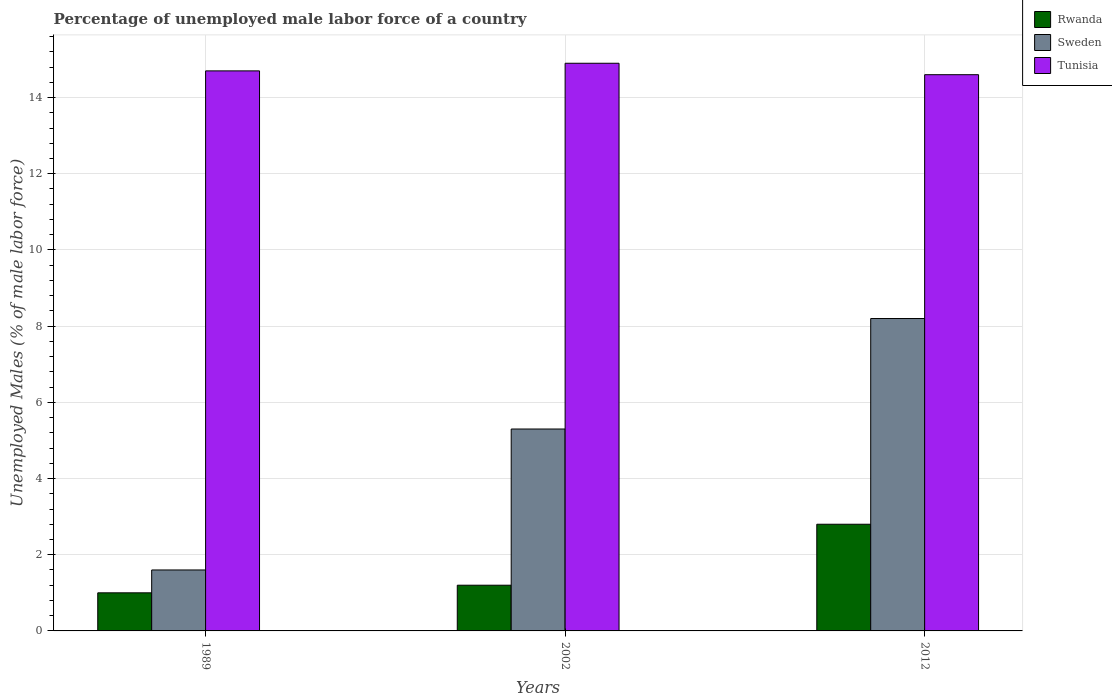How many different coloured bars are there?
Offer a very short reply. 3. How many bars are there on the 1st tick from the left?
Offer a very short reply. 3. What is the label of the 3rd group of bars from the left?
Ensure brevity in your answer.  2012. What is the percentage of unemployed male labor force in Tunisia in 2012?
Provide a short and direct response. 14.6. Across all years, what is the maximum percentage of unemployed male labor force in Rwanda?
Make the answer very short. 2.8. Across all years, what is the minimum percentage of unemployed male labor force in Tunisia?
Keep it short and to the point. 14.6. What is the total percentage of unemployed male labor force in Tunisia in the graph?
Provide a succinct answer. 44.2. What is the difference between the percentage of unemployed male labor force in Tunisia in 1989 and that in 2012?
Your answer should be very brief. 0.1. What is the difference between the percentage of unemployed male labor force in Sweden in 1989 and the percentage of unemployed male labor force in Tunisia in 2002?
Your answer should be compact. -13.3. What is the average percentage of unemployed male labor force in Sweden per year?
Keep it short and to the point. 5.03. In the year 1989, what is the difference between the percentage of unemployed male labor force in Rwanda and percentage of unemployed male labor force in Sweden?
Offer a very short reply. -0.6. What is the ratio of the percentage of unemployed male labor force in Rwanda in 1989 to that in 2002?
Offer a very short reply. 0.83. Is the percentage of unemployed male labor force in Rwanda in 1989 less than that in 2002?
Your answer should be very brief. Yes. Is the difference between the percentage of unemployed male labor force in Rwanda in 2002 and 2012 greater than the difference between the percentage of unemployed male labor force in Sweden in 2002 and 2012?
Your response must be concise. Yes. What is the difference between the highest and the second highest percentage of unemployed male labor force in Sweden?
Your answer should be very brief. 2.9. What is the difference between the highest and the lowest percentage of unemployed male labor force in Rwanda?
Provide a short and direct response. 1.8. What does the 3rd bar from the left in 2012 represents?
Provide a succinct answer. Tunisia. What does the 1st bar from the right in 2002 represents?
Keep it short and to the point. Tunisia. Is it the case that in every year, the sum of the percentage of unemployed male labor force in Tunisia and percentage of unemployed male labor force in Rwanda is greater than the percentage of unemployed male labor force in Sweden?
Provide a short and direct response. Yes. Are all the bars in the graph horizontal?
Make the answer very short. No. How many years are there in the graph?
Your answer should be compact. 3. What is the difference between two consecutive major ticks on the Y-axis?
Your response must be concise. 2. Are the values on the major ticks of Y-axis written in scientific E-notation?
Give a very brief answer. No. Does the graph contain any zero values?
Your answer should be compact. No. Does the graph contain grids?
Make the answer very short. Yes. Where does the legend appear in the graph?
Give a very brief answer. Top right. How many legend labels are there?
Your answer should be very brief. 3. What is the title of the graph?
Provide a short and direct response. Percentage of unemployed male labor force of a country. What is the label or title of the X-axis?
Give a very brief answer. Years. What is the label or title of the Y-axis?
Keep it short and to the point. Unemployed Males (% of male labor force). What is the Unemployed Males (% of male labor force) in Rwanda in 1989?
Provide a short and direct response. 1. What is the Unemployed Males (% of male labor force) of Sweden in 1989?
Offer a very short reply. 1.6. What is the Unemployed Males (% of male labor force) of Tunisia in 1989?
Ensure brevity in your answer.  14.7. What is the Unemployed Males (% of male labor force) of Rwanda in 2002?
Offer a terse response. 1.2. What is the Unemployed Males (% of male labor force) of Sweden in 2002?
Give a very brief answer. 5.3. What is the Unemployed Males (% of male labor force) of Tunisia in 2002?
Offer a terse response. 14.9. What is the Unemployed Males (% of male labor force) of Rwanda in 2012?
Your answer should be compact. 2.8. What is the Unemployed Males (% of male labor force) of Sweden in 2012?
Ensure brevity in your answer.  8.2. What is the Unemployed Males (% of male labor force) of Tunisia in 2012?
Offer a very short reply. 14.6. Across all years, what is the maximum Unemployed Males (% of male labor force) of Rwanda?
Offer a terse response. 2.8. Across all years, what is the maximum Unemployed Males (% of male labor force) of Sweden?
Ensure brevity in your answer.  8.2. Across all years, what is the maximum Unemployed Males (% of male labor force) of Tunisia?
Provide a short and direct response. 14.9. Across all years, what is the minimum Unemployed Males (% of male labor force) in Sweden?
Make the answer very short. 1.6. Across all years, what is the minimum Unemployed Males (% of male labor force) in Tunisia?
Provide a succinct answer. 14.6. What is the total Unemployed Males (% of male labor force) of Sweden in the graph?
Give a very brief answer. 15.1. What is the total Unemployed Males (% of male labor force) in Tunisia in the graph?
Offer a terse response. 44.2. What is the difference between the Unemployed Males (% of male labor force) in Sweden in 1989 and that in 2002?
Give a very brief answer. -3.7. What is the difference between the Unemployed Males (% of male labor force) in Tunisia in 1989 and that in 2002?
Provide a succinct answer. -0.2. What is the difference between the Unemployed Males (% of male labor force) of Sweden in 1989 and that in 2012?
Offer a terse response. -6.6. What is the difference between the Unemployed Males (% of male labor force) of Rwanda in 2002 and that in 2012?
Make the answer very short. -1.6. What is the difference between the Unemployed Males (% of male labor force) of Rwanda in 1989 and the Unemployed Males (% of male labor force) of Sweden in 2002?
Give a very brief answer. -4.3. What is the difference between the Unemployed Males (% of male labor force) in Rwanda in 1989 and the Unemployed Males (% of male labor force) in Tunisia in 2012?
Provide a short and direct response. -13.6. What is the average Unemployed Males (% of male labor force) in Sweden per year?
Provide a succinct answer. 5.03. What is the average Unemployed Males (% of male labor force) in Tunisia per year?
Offer a terse response. 14.73. In the year 1989, what is the difference between the Unemployed Males (% of male labor force) in Rwanda and Unemployed Males (% of male labor force) in Tunisia?
Give a very brief answer. -13.7. In the year 1989, what is the difference between the Unemployed Males (% of male labor force) in Sweden and Unemployed Males (% of male labor force) in Tunisia?
Provide a succinct answer. -13.1. In the year 2002, what is the difference between the Unemployed Males (% of male labor force) of Rwanda and Unemployed Males (% of male labor force) of Sweden?
Ensure brevity in your answer.  -4.1. In the year 2002, what is the difference between the Unemployed Males (% of male labor force) in Rwanda and Unemployed Males (% of male labor force) in Tunisia?
Make the answer very short. -13.7. In the year 2002, what is the difference between the Unemployed Males (% of male labor force) in Sweden and Unemployed Males (% of male labor force) in Tunisia?
Your response must be concise. -9.6. In the year 2012, what is the difference between the Unemployed Males (% of male labor force) in Rwanda and Unemployed Males (% of male labor force) in Sweden?
Give a very brief answer. -5.4. In the year 2012, what is the difference between the Unemployed Males (% of male labor force) in Sweden and Unemployed Males (% of male labor force) in Tunisia?
Offer a terse response. -6.4. What is the ratio of the Unemployed Males (% of male labor force) in Rwanda in 1989 to that in 2002?
Offer a very short reply. 0.83. What is the ratio of the Unemployed Males (% of male labor force) of Sweden in 1989 to that in 2002?
Provide a succinct answer. 0.3. What is the ratio of the Unemployed Males (% of male labor force) of Tunisia in 1989 to that in 2002?
Provide a short and direct response. 0.99. What is the ratio of the Unemployed Males (% of male labor force) in Rwanda in 1989 to that in 2012?
Your answer should be compact. 0.36. What is the ratio of the Unemployed Males (% of male labor force) of Sweden in 1989 to that in 2012?
Your answer should be very brief. 0.2. What is the ratio of the Unemployed Males (% of male labor force) of Tunisia in 1989 to that in 2012?
Offer a very short reply. 1.01. What is the ratio of the Unemployed Males (% of male labor force) of Rwanda in 2002 to that in 2012?
Offer a very short reply. 0.43. What is the ratio of the Unemployed Males (% of male labor force) of Sweden in 2002 to that in 2012?
Ensure brevity in your answer.  0.65. What is the ratio of the Unemployed Males (% of male labor force) in Tunisia in 2002 to that in 2012?
Give a very brief answer. 1.02. What is the difference between the highest and the second highest Unemployed Males (% of male labor force) in Sweden?
Your answer should be compact. 2.9. What is the difference between the highest and the second highest Unemployed Males (% of male labor force) of Tunisia?
Keep it short and to the point. 0.2. 